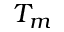<formula> <loc_0><loc_0><loc_500><loc_500>T _ { m }</formula> 